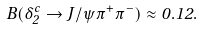Convert formula to latex. <formula><loc_0><loc_0><loc_500><loc_500>B ( \delta ^ { c } _ { 2 } \rightarrow J / \psi \pi ^ { + } \pi ^ { - } ) \approx 0 . 1 2 .</formula> 